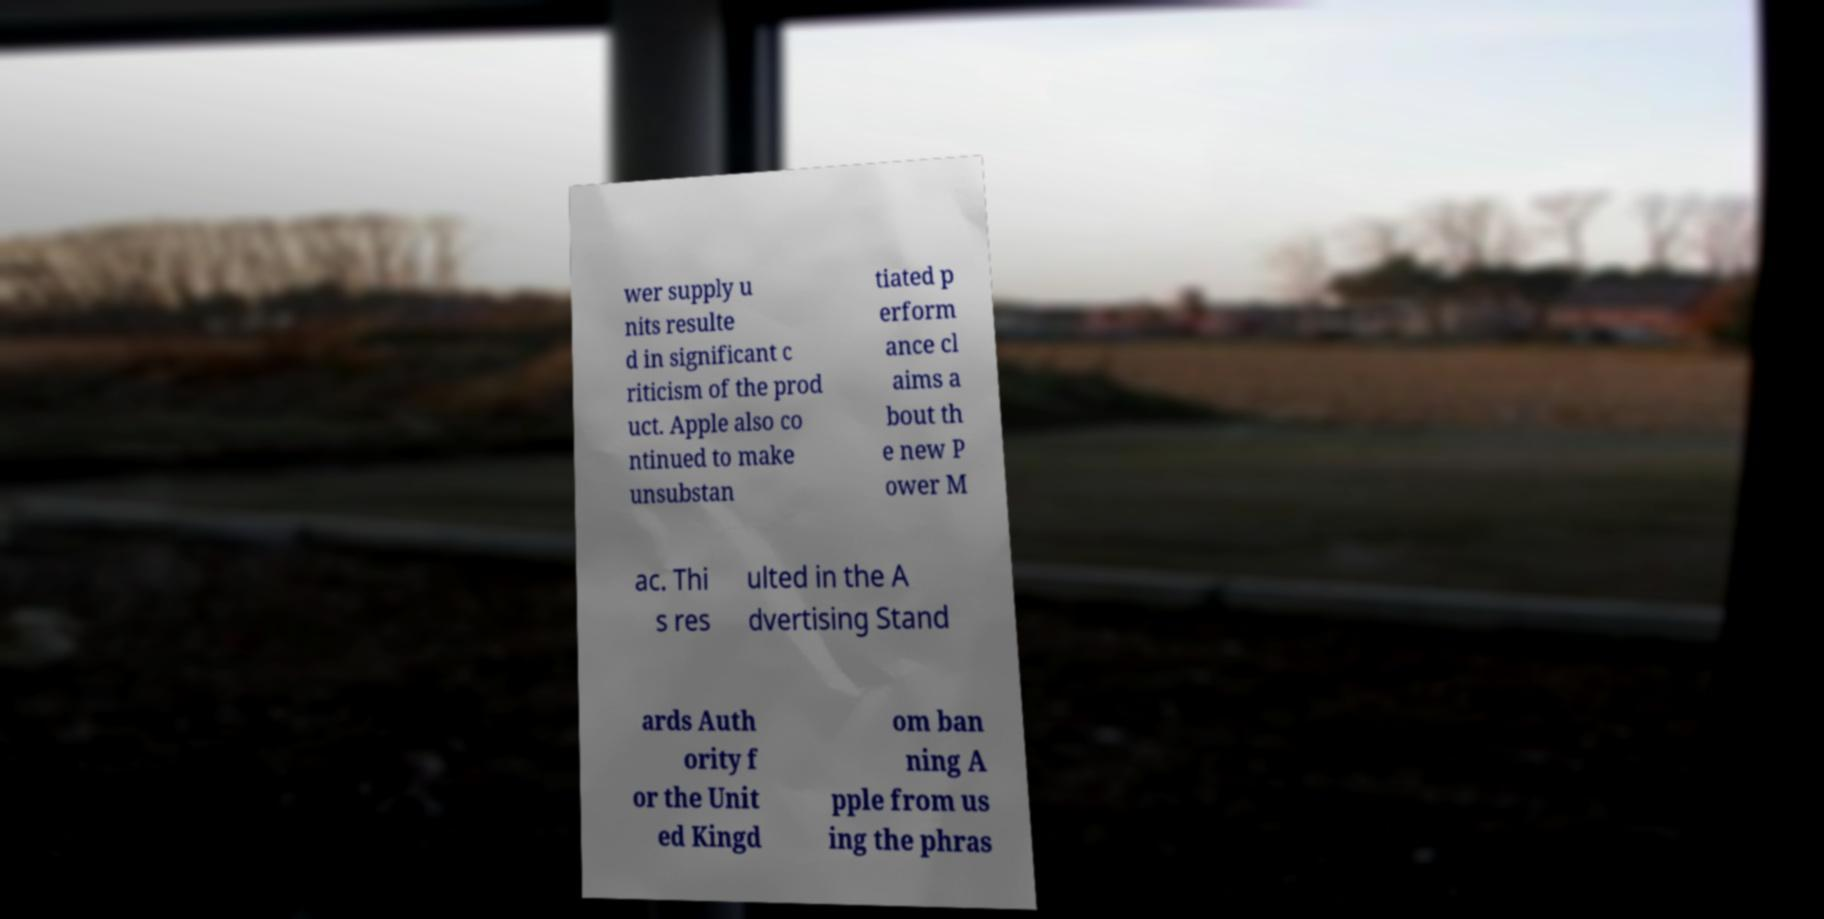For documentation purposes, I need the text within this image transcribed. Could you provide that? wer supply u nits resulte d in significant c riticism of the prod uct. Apple also co ntinued to make unsubstan tiated p erform ance cl aims a bout th e new P ower M ac. Thi s res ulted in the A dvertising Stand ards Auth ority f or the Unit ed Kingd om ban ning A pple from us ing the phras 